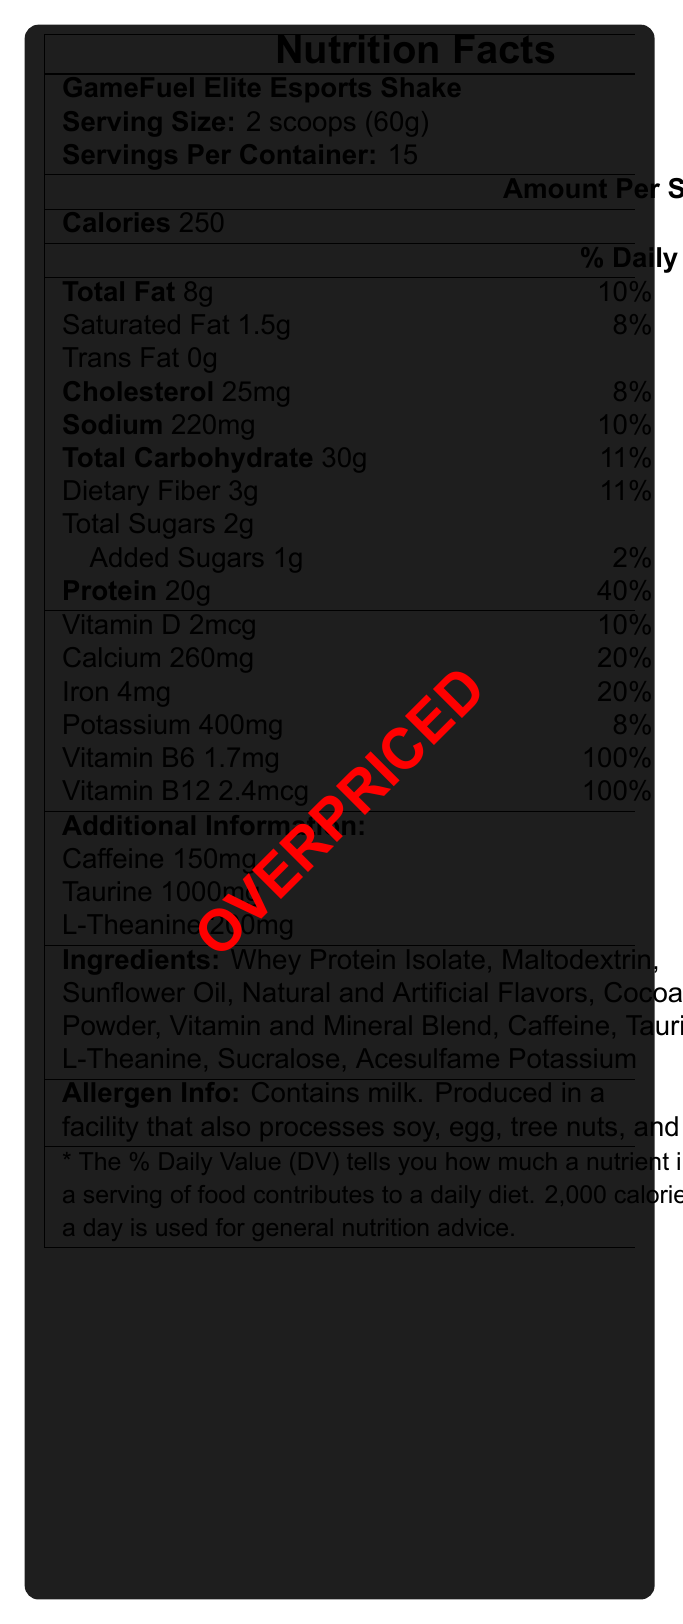what is the serving size of the GameFuel Elite Esports Shake? The serving size is explicitly mentioned on the nutrition label.
Answer: 2 scoops (60g) how many servings are there per container? The document clearly states that there are 15 servings per container.
Answer: 15 how many grams of total fat are in one serving? The Total Fat content is listed as 8g per serving.
Answer: 8g what is the daily value percentage for Vitamin D in one serving? The daily value percentage for Vitamin D is explicitly mentioned as 10%.
Answer: 10% what is the amount of protein per serving? The amount of protein per serving is listed as 20g, making up 40% of the the daily value.
Answer: 20g how much caffeine content does one serving contain? The additional information section states that the caffeine content is 150mg.
Answer: 150mg which ingredient makes up the protein source? A. Maltodextrin B. Sunflower Oil C. Whey Protein Isolate Whey Protein Isolate is listed as the primary ingredient, indicating it as the protein source.
Answer: C what is the percentage of daily value provided by iron in one serving? A. 8% B. 20% C. 40% D. 10% The document shows Iron providing 20% of the Daily Value.
Answer: B how many grams of dietary fiber are in one serving? A. 2g B. 3g C. 4g D. 5g The nutritional label lists the dietary fiber content as 3g per serving.
Answer: B is there any trans fat in a serving of GameFuel Elite Esports Shake? The document explicitly mentions that there is 0g of trans fat.
Answer: No summarize the primary nutritional benefits and marketing claims of the GameFuel Elite Esports Shake. The summary incorporates the main points from the nutrition facts, ingredients, marketing claims, and reviewer notes sections.
Answer: The GameFuel Elite Esports Shake is marketed as a meal replacement shake for esports athletes and aims to support mental focus and reaction time with a high protein, low sugar formula. It includes essential vitamins and minerals, caffeine, taurine, and L-theanine. However, the reviewer notes question its effectiveness for serious athletes and find it overpriced compared to standard meal replacements. what is the total carbohydrate amount per serving in GameFuel Elite Esports Shake? The label indicates that the total carbohydrate content per serving is 30g.
Answer: 30g does the shake contain any cholesterol? The cholesterol content per serving is listed as 25mg.
Answer: Yes which vitamin provides 100% of the daily value in a serving? Both Vitamin B6 and Vitamin B12 supply 100% of the daily value in one serving.
Answer: Vitamin B6 and Vitamin B12 is there any information about the shake's effectiveness for serious athletes? The reviewer notes mention that the shake's effectiveness for serious athletes is questionable.
Answer: Yes what are the main ingredients of the GameFuel Elite Esports Shake? The main ingredients are listed in the ingredients section of the nutrition label.
Answer: Whey Protein Isolate, Maltodextrin, Sunflower Oil, Natural and Artificial Flavors, Cocoa Powder, Vitamin and Mineral Blend, Caffeine, Taurine, L-Theanine, Sucralose, Acesulfame Potassium who is the target consumer for this product based on the marketing claims? The marketing claims specifically mention that the shake is formulated for esports athletes and supports mental focus and reaction time.
Answer: Esports athletes what are the primary sweeteners used in the shake? The ingredients list Sucralose and Acesulfame Potassium as the primary sweeteners.
Answer: Sucralose, Acesulfame Potassium how much Potassium does one serving provide? The nutritional label states that each serving contains 400mg of Potassium.
Answer: 400mg what are the possible allergens in the GameFuel Elite Esports Shake? The allergen information clearly states that the shake contains milk and is produced in a facility that may also process other common allergens.
Answer: Milk, and it is produced in a facility that processes soy, egg, tree nuts, and wheat what is the price of the GameFuel Elite Esports Shake? The price of the product is not mentioned within the provided document, making it impossible to determine.
Answer: Not enough information 